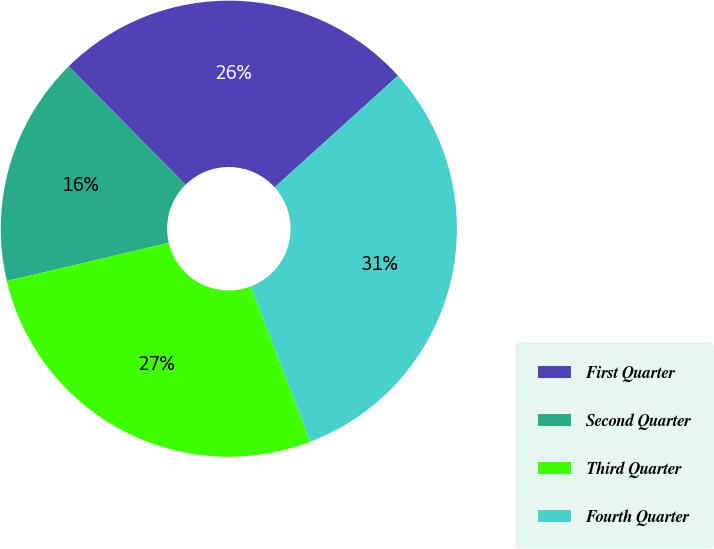Convert chart to OTSL. <chart><loc_0><loc_0><loc_500><loc_500><pie_chart><fcel>First Quarter<fcel>Second Quarter<fcel>Third Quarter<fcel>Fourth Quarter<nl><fcel>25.68%<fcel>16.3%<fcel>27.14%<fcel>30.89%<nl></chart> 